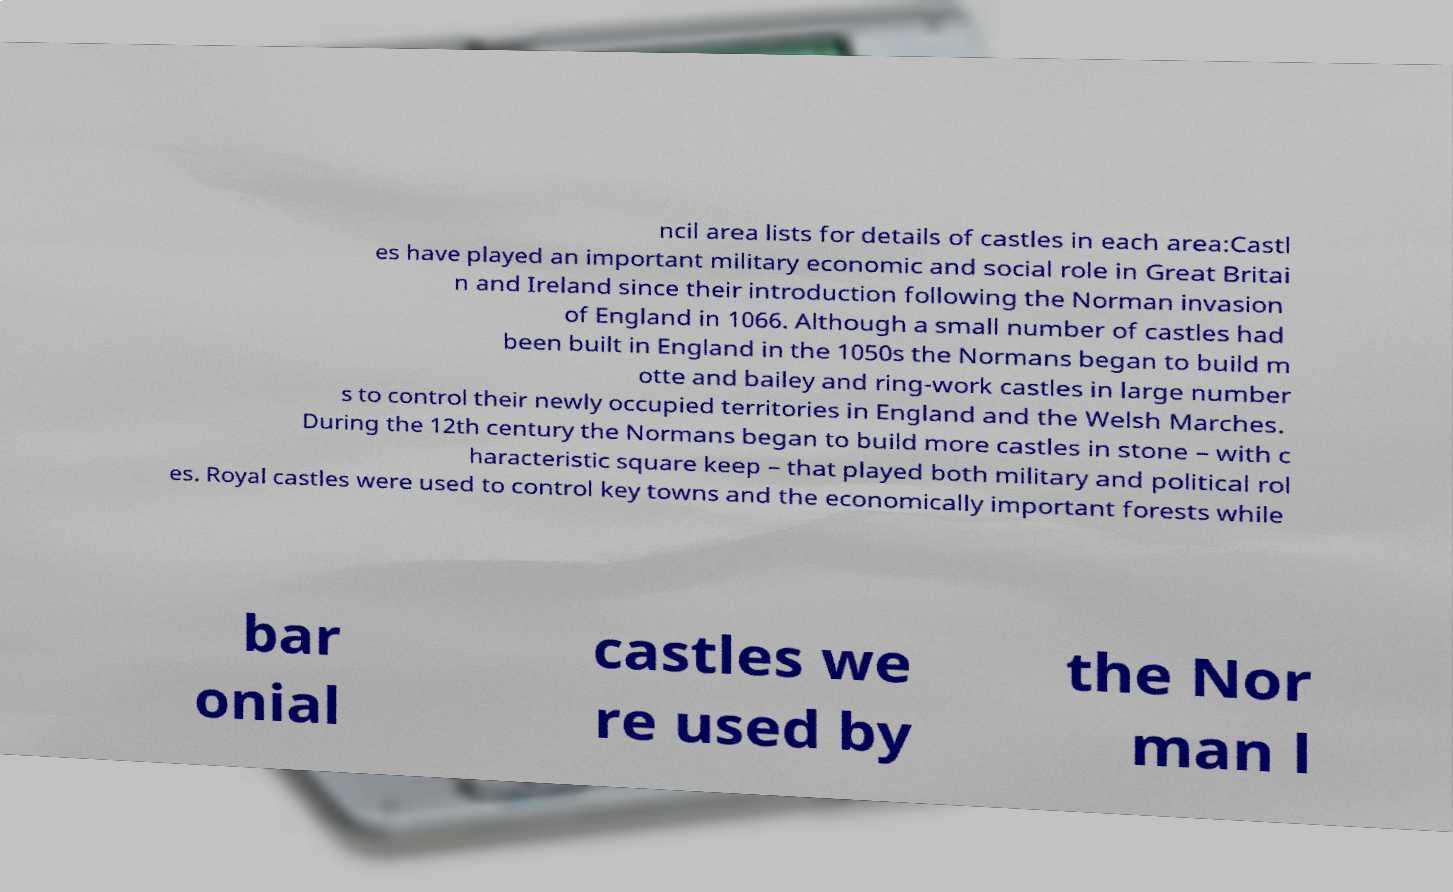There's text embedded in this image that I need extracted. Can you transcribe it verbatim? ncil area lists for details of castles in each area:Castl es have played an important military economic and social role in Great Britai n and Ireland since their introduction following the Norman invasion of England in 1066. Although a small number of castles had been built in England in the 1050s the Normans began to build m otte and bailey and ring-work castles in large number s to control their newly occupied territories in England and the Welsh Marches. During the 12th century the Normans began to build more castles in stone – with c haracteristic square keep – that played both military and political rol es. Royal castles were used to control key towns and the economically important forests while bar onial castles we re used by the Nor man l 